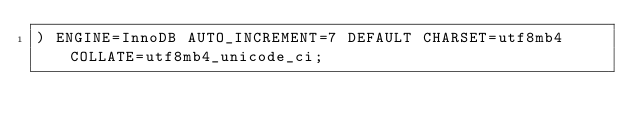<code> <loc_0><loc_0><loc_500><loc_500><_SQL_>) ENGINE=InnoDB AUTO_INCREMENT=7 DEFAULT CHARSET=utf8mb4 COLLATE=utf8mb4_unicode_ci;
</code> 